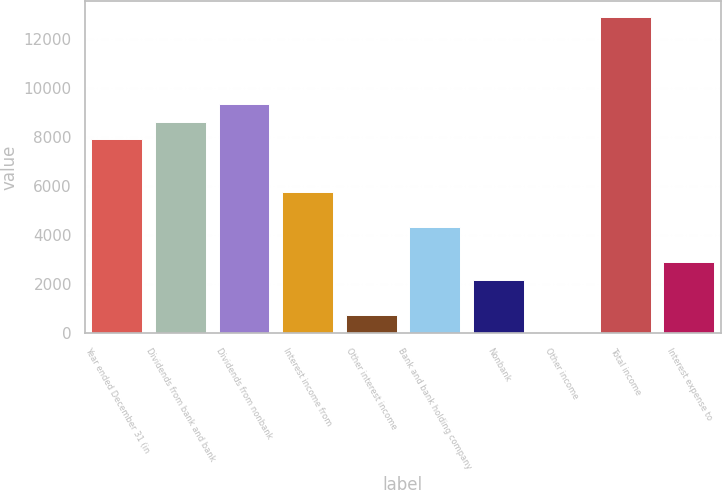Convert chart to OTSL. <chart><loc_0><loc_0><loc_500><loc_500><bar_chart><fcel>Year ended December 31 (in<fcel>Dividends from bank and bank<fcel>Dividends from nonbank<fcel>Interest income from<fcel>Other interest income<fcel>Bank and bank holding company<fcel>Nonbank<fcel>Other income<fcel>Total income<fcel>Interest expense to<nl><fcel>7907.6<fcel>8624.2<fcel>9340.8<fcel>5757.8<fcel>741.6<fcel>4324.6<fcel>2174.8<fcel>25<fcel>12923.8<fcel>2891.4<nl></chart> 